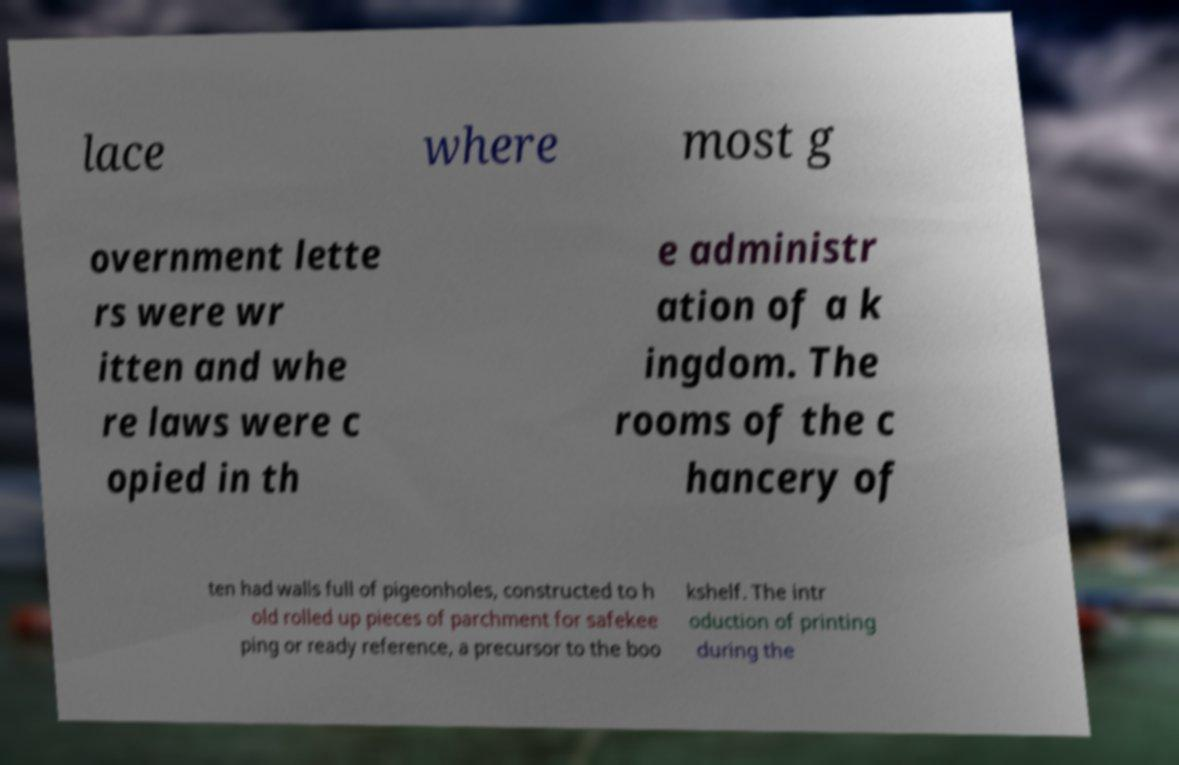Can you accurately transcribe the text from the provided image for me? lace where most g overnment lette rs were wr itten and whe re laws were c opied in th e administr ation of a k ingdom. The rooms of the c hancery of ten had walls full of pigeonholes, constructed to h old rolled up pieces of parchment for safekee ping or ready reference, a precursor to the boo kshelf. The intr oduction of printing during the 